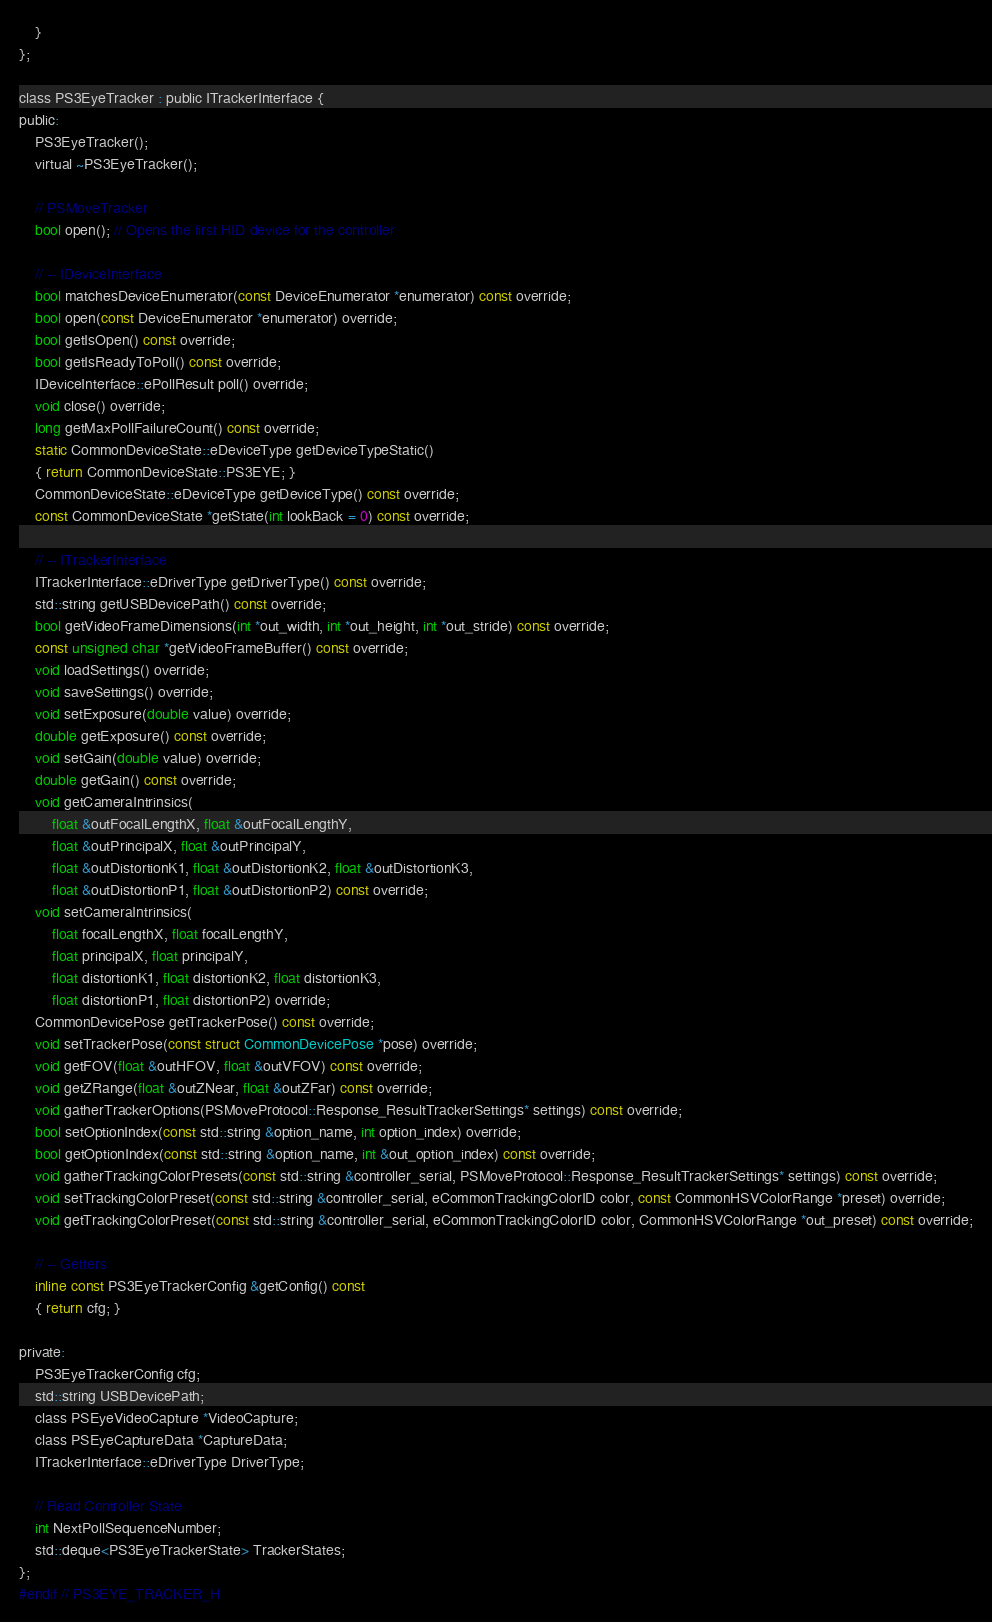Convert code to text. <code><loc_0><loc_0><loc_500><loc_500><_C_>    }
};

class PS3EyeTracker : public ITrackerInterface {
public:
    PS3EyeTracker();
    virtual ~PS3EyeTracker();
        
    // PSMoveTracker
    bool open(); // Opens the first HID device for the controller
    
    // -- IDeviceInterface
    bool matchesDeviceEnumerator(const DeviceEnumerator *enumerator) const override;
    bool open(const DeviceEnumerator *enumerator) override;
    bool getIsOpen() const override;
    bool getIsReadyToPoll() const override;
    IDeviceInterface::ePollResult poll() override;
    void close() override;
    long getMaxPollFailureCount() const override;
    static CommonDeviceState::eDeviceType getDeviceTypeStatic()
    { return CommonDeviceState::PS3EYE; }
    CommonDeviceState::eDeviceType getDeviceType() const override;
    const CommonDeviceState *getState(int lookBack = 0) const override;
    
    // -- ITrackerInterface
    ITrackerInterface::eDriverType getDriverType() const override;
    std::string getUSBDevicePath() const override;
    bool getVideoFrameDimensions(int *out_width, int *out_height, int *out_stride) const override;
    const unsigned char *getVideoFrameBuffer() const override;
    void loadSettings() override;
    void saveSettings() override;
    void setExposure(double value) override;
    double getExposure() const override;
	void setGain(double value) override;
	double getGain() const override;
    void getCameraIntrinsics(
        float &outFocalLengthX, float &outFocalLengthY,
        float &outPrincipalX, float &outPrincipalY,
        float &outDistortionK1, float &outDistortionK2, float &outDistortionK3,
        float &outDistortionP1, float &outDistortionP2) const override;
    void setCameraIntrinsics(
        float focalLengthX, float focalLengthY,
        float principalX, float principalY,
        float distortionK1, float distortionK2, float distortionK3,
        float distortionP1, float distortionP2) override;
    CommonDevicePose getTrackerPose() const override;
    void setTrackerPose(const struct CommonDevicePose *pose) override;
    void getFOV(float &outHFOV, float &outVFOV) const override;
    void getZRange(float &outZNear, float &outZFar) const override;
    void gatherTrackerOptions(PSMoveProtocol::Response_ResultTrackerSettings* settings) const override;
    bool setOptionIndex(const std::string &option_name, int option_index) override;
    bool getOptionIndex(const std::string &option_name, int &out_option_index) const override;
    void gatherTrackingColorPresets(const std::string &controller_serial, PSMoveProtocol::Response_ResultTrackerSettings* settings) const override;
    void setTrackingColorPreset(const std::string &controller_serial, eCommonTrackingColorID color, const CommonHSVColorRange *preset) override;
    void getTrackingColorPreset(const std::string &controller_serial, eCommonTrackingColorID color, CommonHSVColorRange *out_preset) const override;

    // -- Getters
    inline const PS3EyeTrackerConfig &getConfig() const
    { return cfg; }

private:
    PS3EyeTrackerConfig cfg;
    std::string USBDevicePath;
    class PSEyeVideoCapture *VideoCapture;
    class PSEyeCaptureData *CaptureData;
    ITrackerInterface::eDriverType DriverType;    
    
    // Read Controller State
    int NextPollSequenceNumber;
    std::deque<PS3EyeTrackerState> TrackerStates;
};
#endif // PS3EYE_TRACKER_H
</code> 